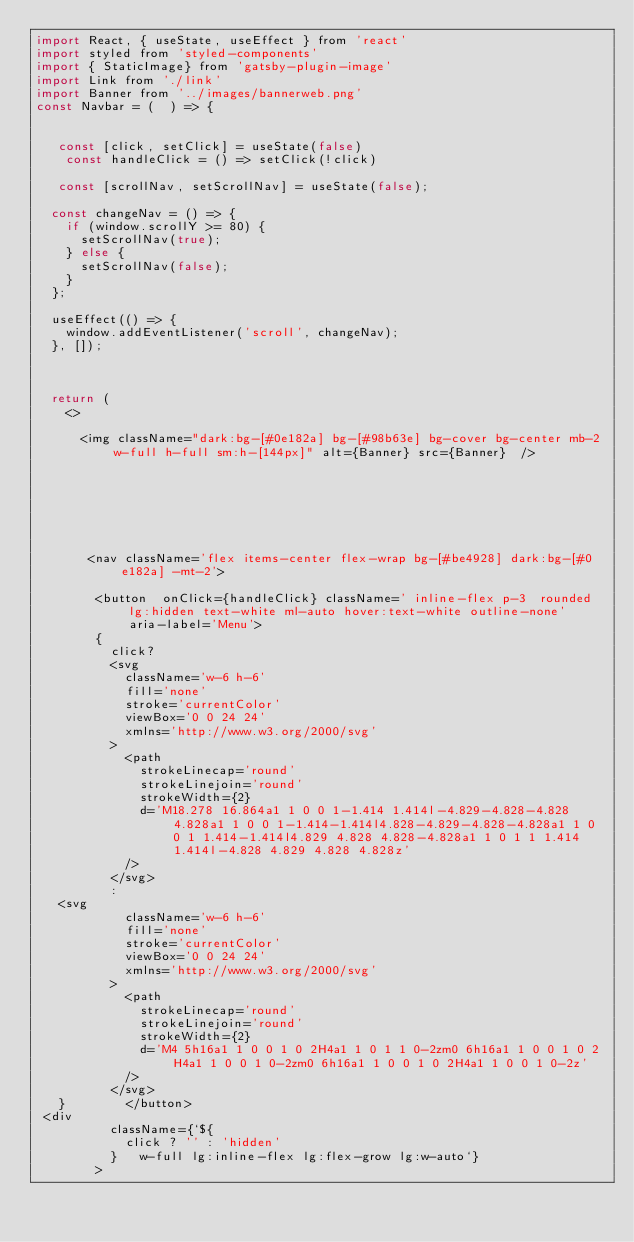Convert code to text. <code><loc_0><loc_0><loc_500><loc_500><_JavaScript_>import React, { useState, useEffect } from 'react'
import styled from 'styled-components'
import { StaticImage} from 'gatsby-plugin-image'
import Link from './link'
import Banner from '../images/bannerweb.png'
const Navbar = (  ) => {


   const [click, setClick] = useState(false) 
    const handleClick = () => setClick(!click)

   const [scrollNav, setScrollNav] = useState(false);

  const changeNav = () => {
    if (window.scrollY >= 80) {
      setScrollNav(true);
    } else {
      setScrollNav(false);
    }
  };

  useEffect(() => {
    window.addEventListener('scroll', changeNav);
  }, []);



  return (
    <>
 
      <img className="dark:bg-[#0e182a] bg-[#98b63e] bg-cover bg-center mb-2 w-full h-full sm:h-[144px]" alt={Banner} src={Banner}  />


      
    



       <nav className='flex items-center flex-wrap bg-[#be4928] dark:bg-[#0e182a] -mt-2'>
      
        <button  onClick={handleClick} className=' inline-flex p-3  rounded lg:hidden text-white ml-auto hover:text-white outline-none'  aria-label='Menu'>
        {
          click?
          <svg
            className='w-6 h-6'
            fill='none'
            stroke='currentColor'
            viewBox='0 0 24 24'
            xmlns='http://www.w3.org/2000/svg'
          >
            <path
              strokeLinecap='round'
              strokeLinejoin='round'
              strokeWidth={2}
              d='M18.278 16.864a1 1 0 0 1-1.414 1.414l-4.829-4.828-4.828 4.828a1 1 0 0 1-1.414-1.414l4.828-4.829-4.828-4.828a1 1 0 0 1 1.414-1.414l4.829 4.828 4.828-4.828a1 1 0 1 1 1.414 1.414l-4.828 4.829 4.828 4.828z'
            />
          </svg>
          :
   <svg
            className='w-6 h-6'
            fill='none'
            stroke='currentColor'
            viewBox='0 0 24 24'
            xmlns='http://www.w3.org/2000/svg'
          >
            <path
              strokeLinecap='round'
              strokeLinejoin='round'
              strokeWidth={2}
              d='M4 5h16a1 1 0 0 1 0 2H4a1 1 0 1 1 0-2zm0 6h16a1 1 0 0 1 0 2H4a1 1 0 0 1 0-2zm0 6h16a1 1 0 0 1 0 2H4a1 1 0 0 1 0-2z'
            />
          </svg>
   }        </button>
 <div
          className={`${
            click ? '' : 'hidden'
          }   w-full lg:inline-flex lg:flex-grow lg:w-auto`}
        ></code> 